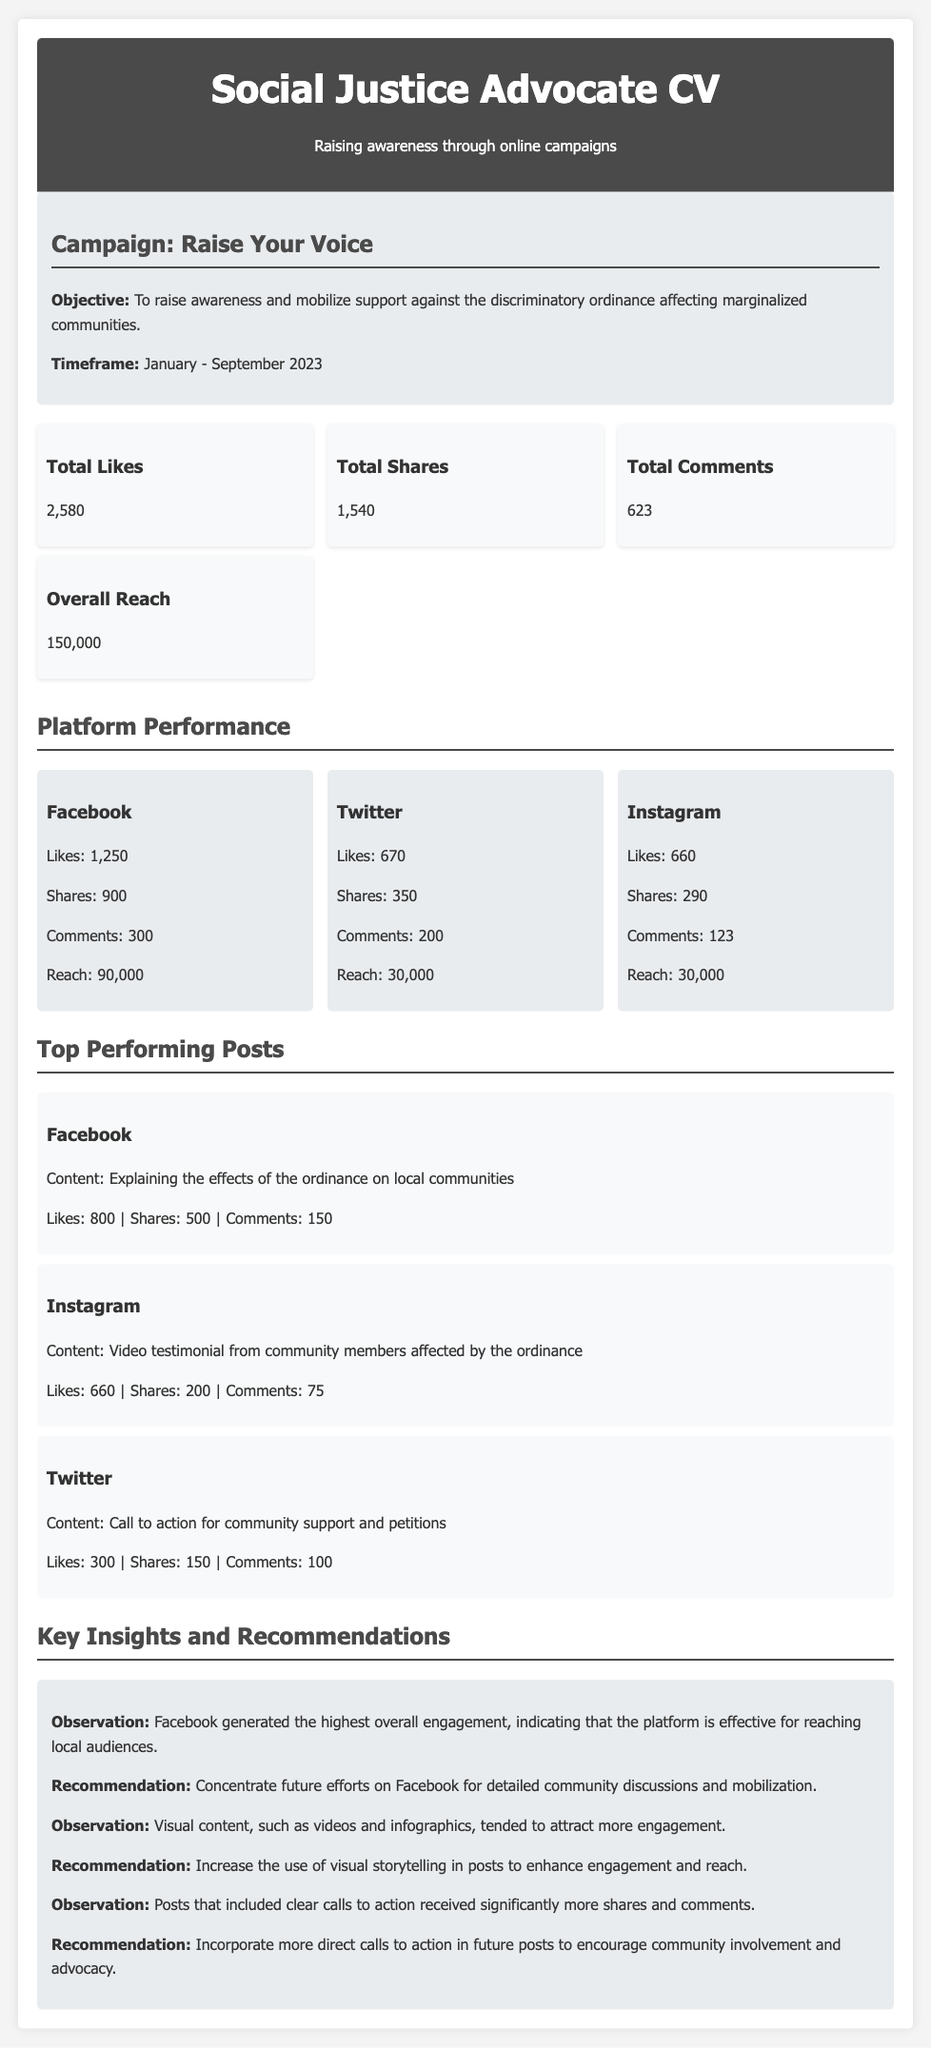what is the total number of likes? The total number of likes is presented as a specific metric in the document.
Answer: 2,580 what is the total reach of the campaign? Total reach represents the combined visibility of all posts in the campaign, given as a single number.
Answer: 150,000 which platform had the highest number of shares? The platform with the highest shares is identified in the platform performance section of the document.
Answer: Facebook what was the timeframe of the campaign? The timeframe is explicitly outlined in the campaign information section.
Answer: January - September 2023 what type of content generated the most engagement? The document states that visual content attracted more engagement, requiring reasoning about multiple observations.
Answer: Visual content which post received the most likes? The likes for each top performing post can be compared to find the one with the highest number of likes.
Answer: 800 what is the objective of the campaign? The objective is clearly mentioned in the campaign info section and summarizes the goal of the campaign.
Answer: To raise awareness and mobilize support against the discriminatory ordinance what is a key recommendation for future posts? The document suggests recommendations for improving engagement, combining observations from the insights section.
Answer: Incorporate more direct calls to action what is the total number of comments across all platforms? The total number of comments is the sum of comments from each platform provided in the data and must be calculated.
Answer: 623 